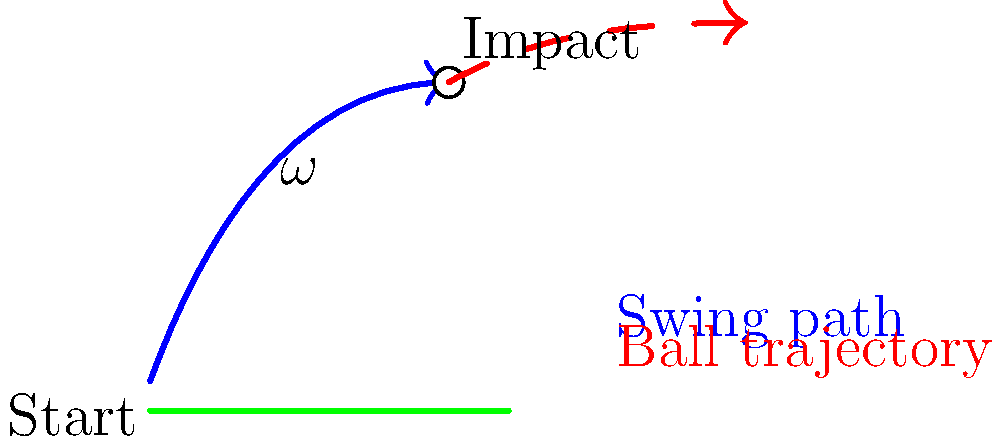As an investment consultant analyzing the potential of a golf equipment company, you're studying the biomechanics of a golf swing. The graphic shows the swing path and ball trajectory. If the angular velocity ($\omega$) of the club head at impact is 400 rad/s and the club length is 1 meter, what is the linear velocity of the club head at impact in m/s? To solve this problem, we'll use the relationship between angular velocity and linear velocity in circular motion. Here's a step-by-step explanation:

1. Recall the formula relating angular velocity ($\omega$) to linear velocity ($v$):
   
   $v = \omega r$

   Where:
   $v$ is the linear velocity
   $\omega$ is the angular velocity
   $r$ is the radius (in this case, the club length)

2. We're given:
   $\omega = 400$ rad/s
   $r = 1$ meter

3. Substituting these values into the formula:

   $v = 400 \text{ rad/s} \times 1 \text{ m}$

4. Simplify:

   $v = 400 \text{ m/s}$

This high velocity illustrates why golf equipment companies invest heavily in club head design and materials to optimize energy transfer and control.
Answer: 400 m/s 